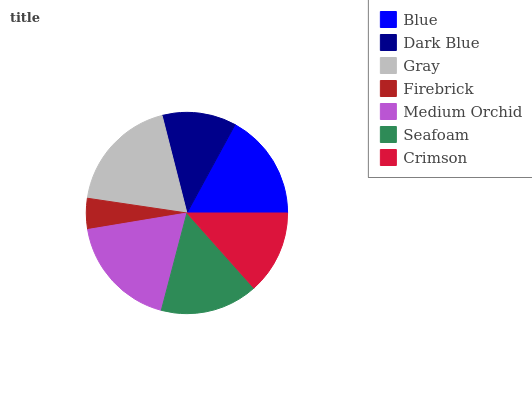Is Firebrick the minimum?
Answer yes or no. Yes. Is Gray the maximum?
Answer yes or no. Yes. Is Dark Blue the minimum?
Answer yes or no. No. Is Dark Blue the maximum?
Answer yes or no. No. Is Blue greater than Dark Blue?
Answer yes or no. Yes. Is Dark Blue less than Blue?
Answer yes or no. Yes. Is Dark Blue greater than Blue?
Answer yes or no. No. Is Blue less than Dark Blue?
Answer yes or no. No. Is Seafoam the high median?
Answer yes or no. Yes. Is Seafoam the low median?
Answer yes or no. Yes. Is Crimson the high median?
Answer yes or no. No. Is Blue the low median?
Answer yes or no. No. 